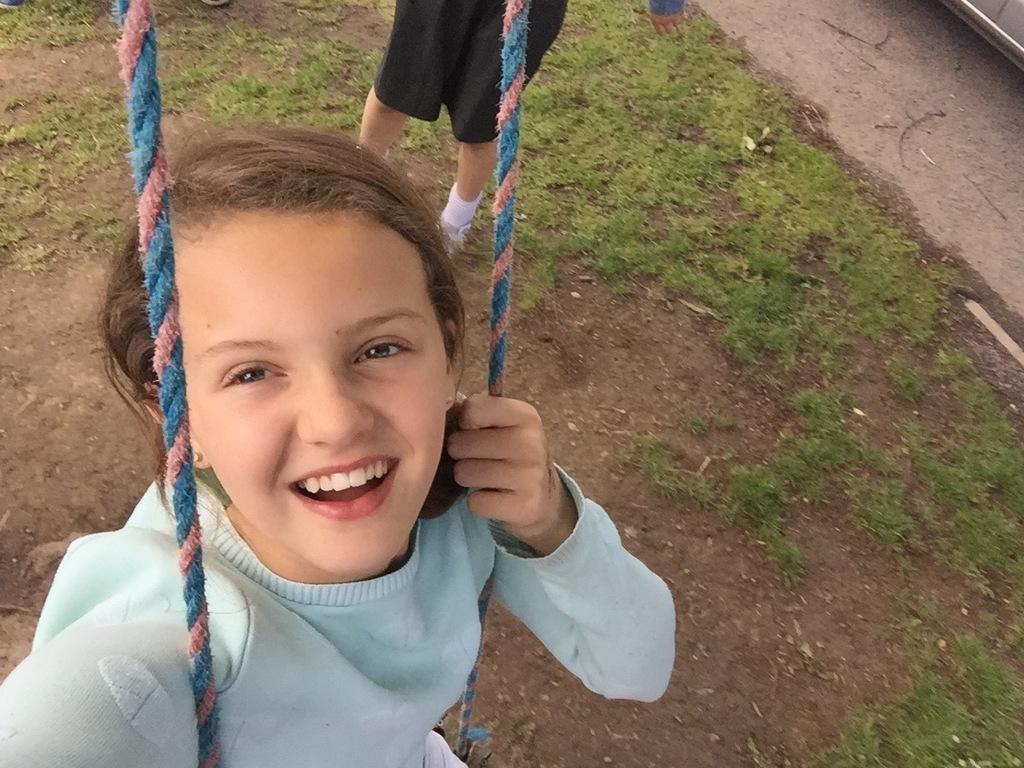In one or two sentences, can you explain what this image depicts? In this picture we can see a girl here, at the bottom there is soil and grass, we can see another person here. 